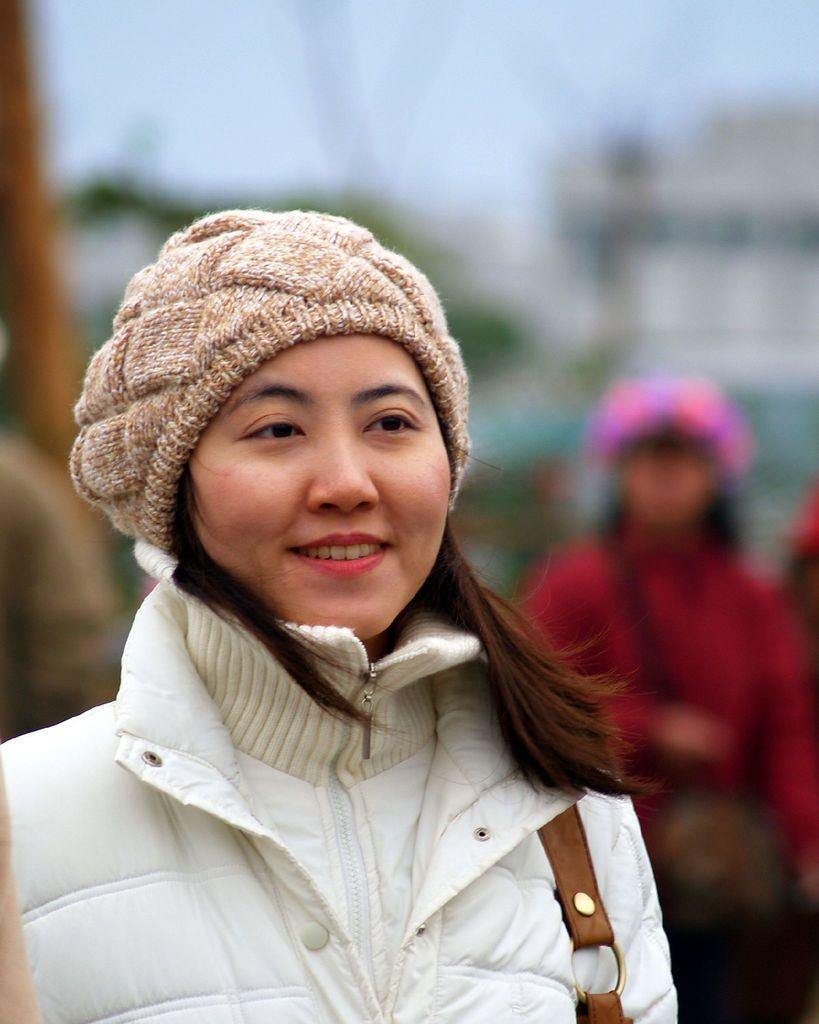Who is the main subject in the image? There is a woman in the image. What is the woman doing in the image? The woman is standing and smiling. Are there any other people in the image? Yes, there are people standing behind the woman. How would you describe the background of the image? The background of the image is blurred. What type of grain is being harvested in the background of the image? There is no grain or harvesting activity present in the image; the background is blurred. 